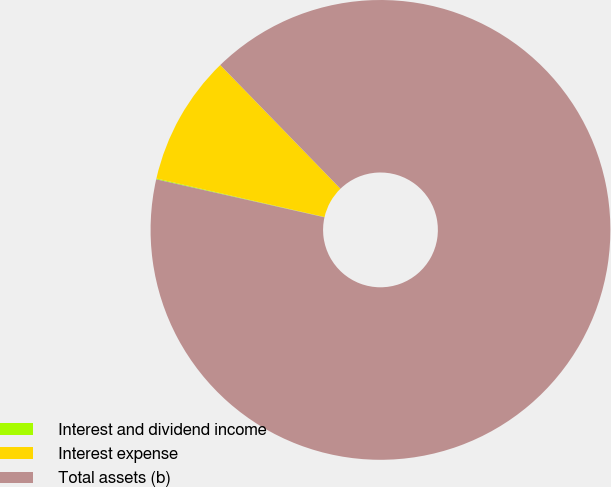Convert chart to OTSL. <chart><loc_0><loc_0><loc_500><loc_500><pie_chart><fcel>Interest and dividend income<fcel>Interest expense<fcel>Total assets (b)<nl><fcel>0.06%<fcel>9.14%<fcel>90.8%<nl></chart> 